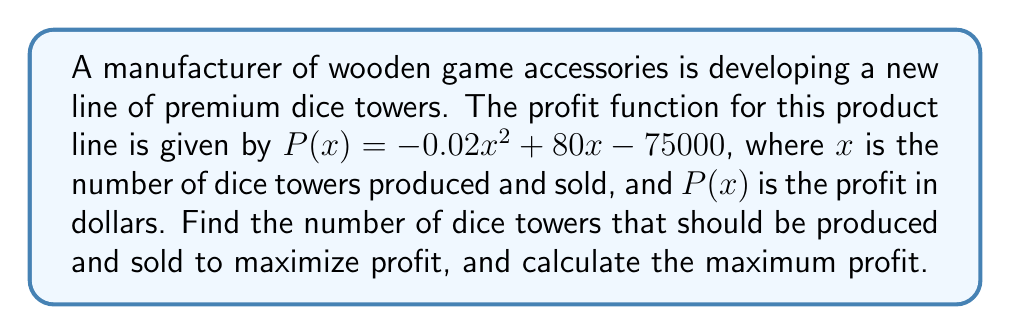Can you solve this math problem? To find the maximum profit point, we need to follow these steps:

1. Find the derivative of the profit function:
   $$P'(x) = -0.04x + 80$$

2. Set the derivative equal to zero and solve for x:
   $$-0.04x + 80 = 0$$
   $$-0.04x = -80$$
   $$x = 2000$$

3. Verify that this critical point is a maximum by checking the second derivative:
   $$P''(x) = -0.04$$
   Since $P''(x)$ is negative, the critical point is a maximum.

4. Calculate the maximum profit by substituting x = 2000 into the original profit function:
   $$P(2000) = -0.02(2000)^2 + 80(2000) - 75000$$
   $$= -80000 + 160000 - 75000$$
   $$= 5000$$

Therefore, the manufacturer should produce and sell 2000 dice towers to maximize profit, and the maximum profit will be $5000.
Answer: 2000 dice towers; $5000 maximum profit 